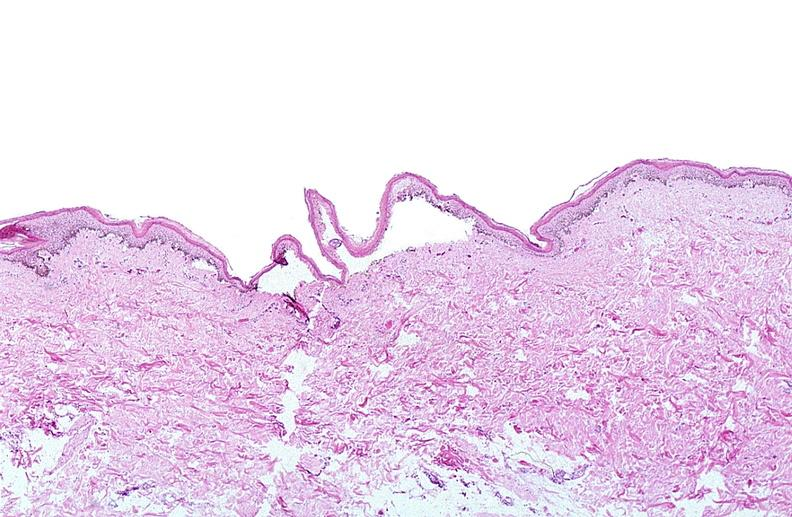does soft tissue show thermal burned skin?
Answer the question using a single word or phrase. No 